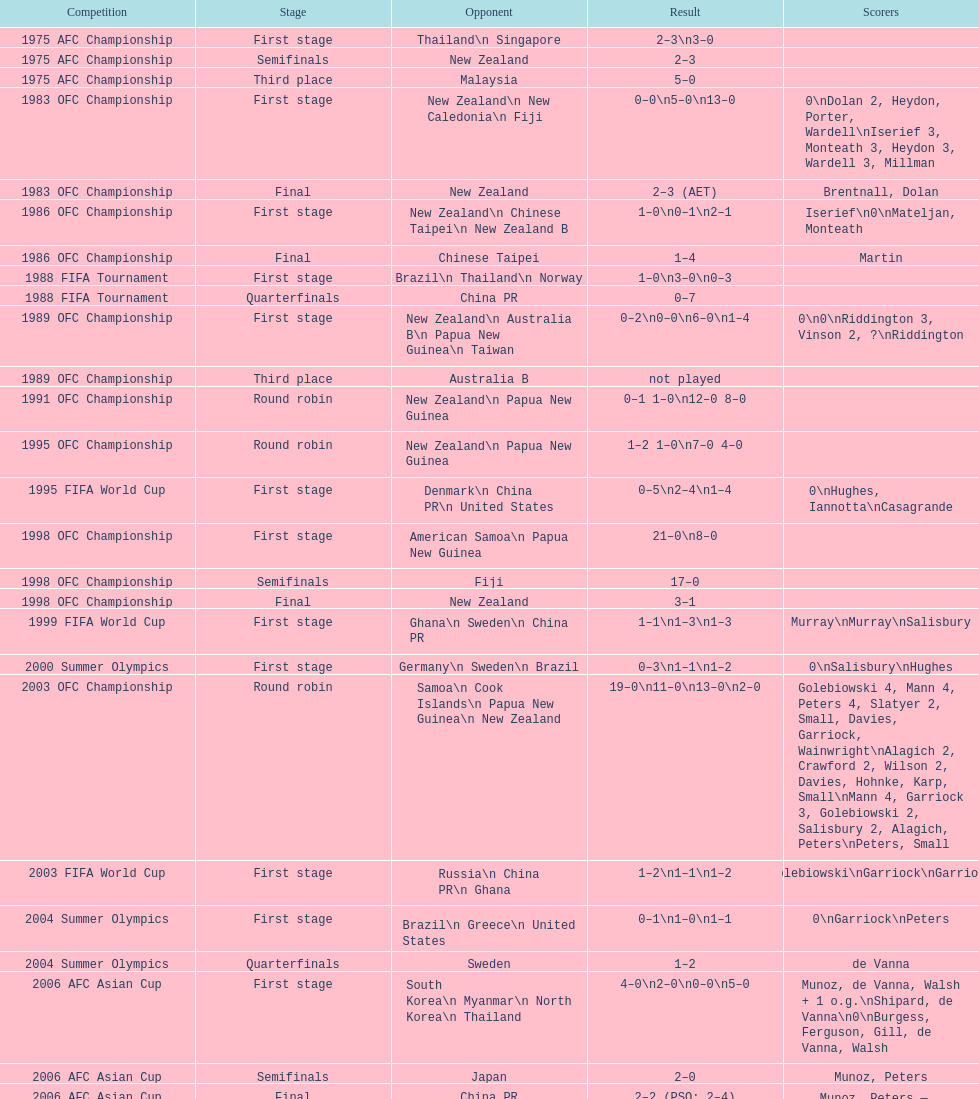Between denmark and the united states, who had a superior performance in the 1995 fifa world cup? United States. 